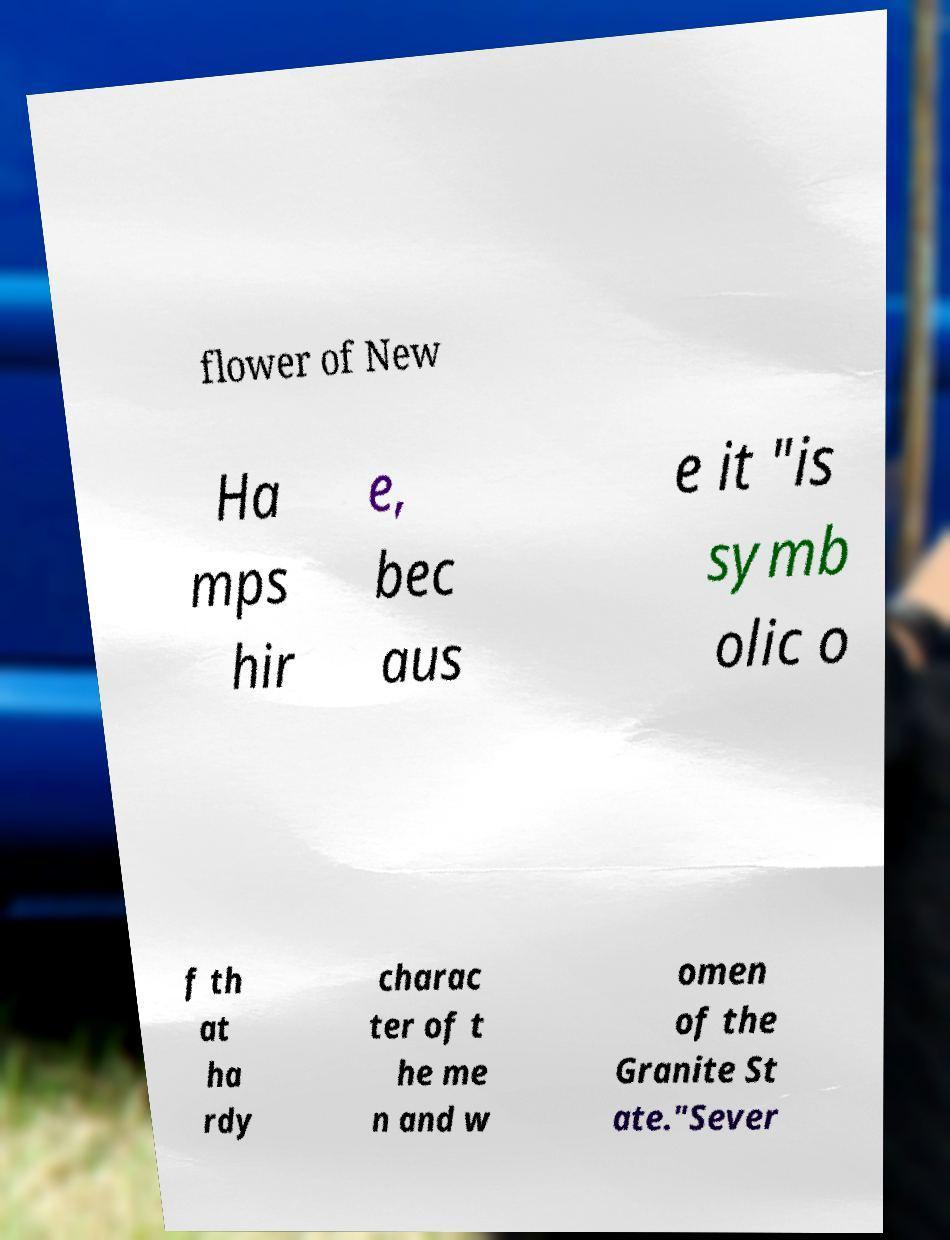I need the written content from this picture converted into text. Can you do that? flower of New Ha mps hir e, bec aus e it "is symb olic o f th at ha rdy charac ter of t he me n and w omen of the Granite St ate."Sever 